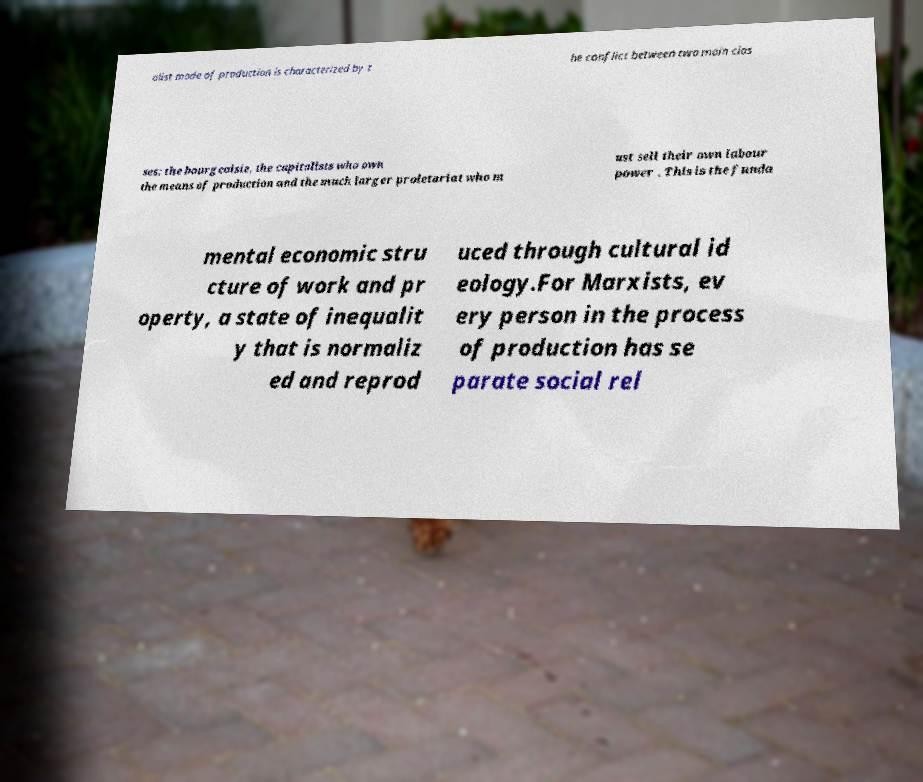Please read and relay the text visible in this image. What does it say? alist mode of production is characterized by t he conflict between two main clas ses: the bourgeoisie, the capitalists who own the means of production and the much larger proletariat who m ust sell their own labour power . This is the funda mental economic stru cture of work and pr operty, a state of inequalit y that is normaliz ed and reprod uced through cultural id eology.For Marxists, ev ery person in the process of production has se parate social rel 